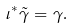Convert formula to latex. <formula><loc_0><loc_0><loc_500><loc_500>\iota ^ { * } \tilde { \gamma } = \gamma .</formula> 